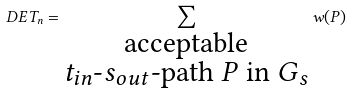<formula> <loc_0><loc_0><loc_500><loc_500>\ D E T _ { n } = \sum _ { \substack { \text {acceptable} \\ \text {$t_{in}$-$s_{out}$-path $P$ in $G_{s}$} } } w ( P )</formula> 